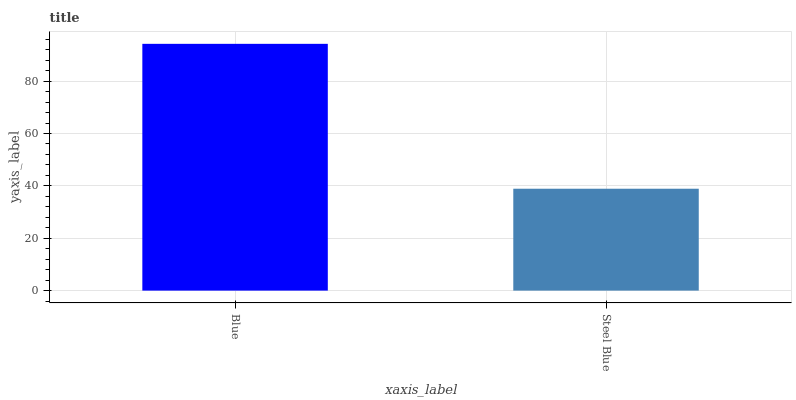Is Steel Blue the minimum?
Answer yes or no. Yes. Is Blue the maximum?
Answer yes or no. Yes. Is Steel Blue the maximum?
Answer yes or no. No. Is Blue greater than Steel Blue?
Answer yes or no. Yes. Is Steel Blue less than Blue?
Answer yes or no. Yes. Is Steel Blue greater than Blue?
Answer yes or no. No. Is Blue less than Steel Blue?
Answer yes or no. No. Is Blue the high median?
Answer yes or no. Yes. Is Steel Blue the low median?
Answer yes or no. Yes. Is Steel Blue the high median?
Answer yes or no. No. Is Blue the low median?
Answer yes or no. No. 